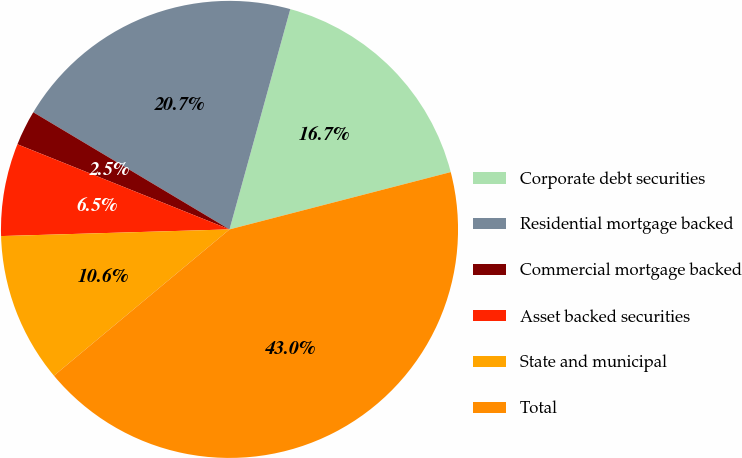Convert chart to OTSL. <chart><loc_0><loc_0><loc_500><loc_500><pie_chart><fcel>Corporate debt securities<fcel>Residential mortgage backed<fcel>Commercial mortgage backed<fcel>Asset backed securities<fcel>State and municipal<fcel>Total<nl><fcel>16.68%<fcel>20.72%<fcel>2.49%<fcel>6.54%<fcel>10.59%<fcel>42.98%<nl></chart> 